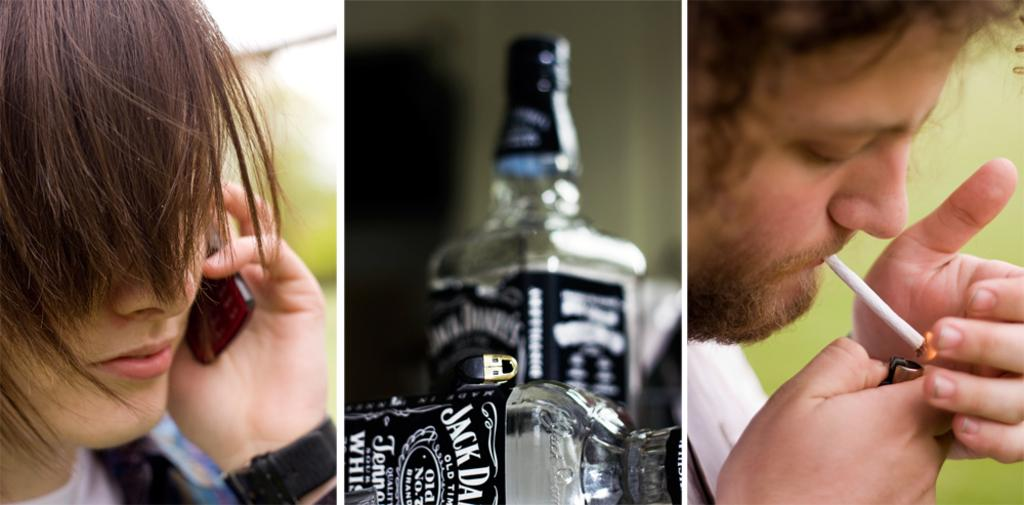<image>
Describe the image concisely. Collage of three pictures with two empty Jack Daniels bottles in the bottle. 